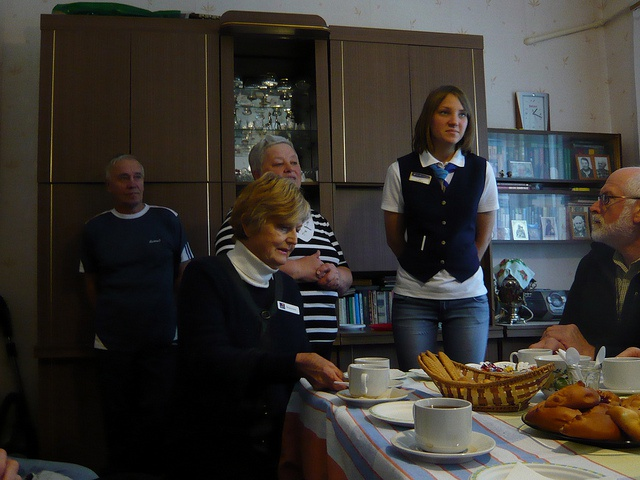Describe the objects in this image and their specific colors. I can see dining table in gray, darkgray, black, and maroon tones, people in gray, black, maroon, and olive tones, people in gray, black, darkgray, and navy tones, people in gray, black, and maroon tones, and people in gray, black, and maroon tones in this image. 